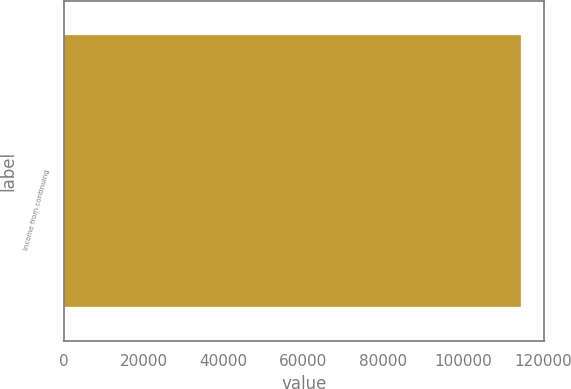Convert chart. <chart><loc_0><loc_0><loc_500><loc_500><bar_chart><fcel>Income from continuing<nl><fcel>114477<nl></chart> 